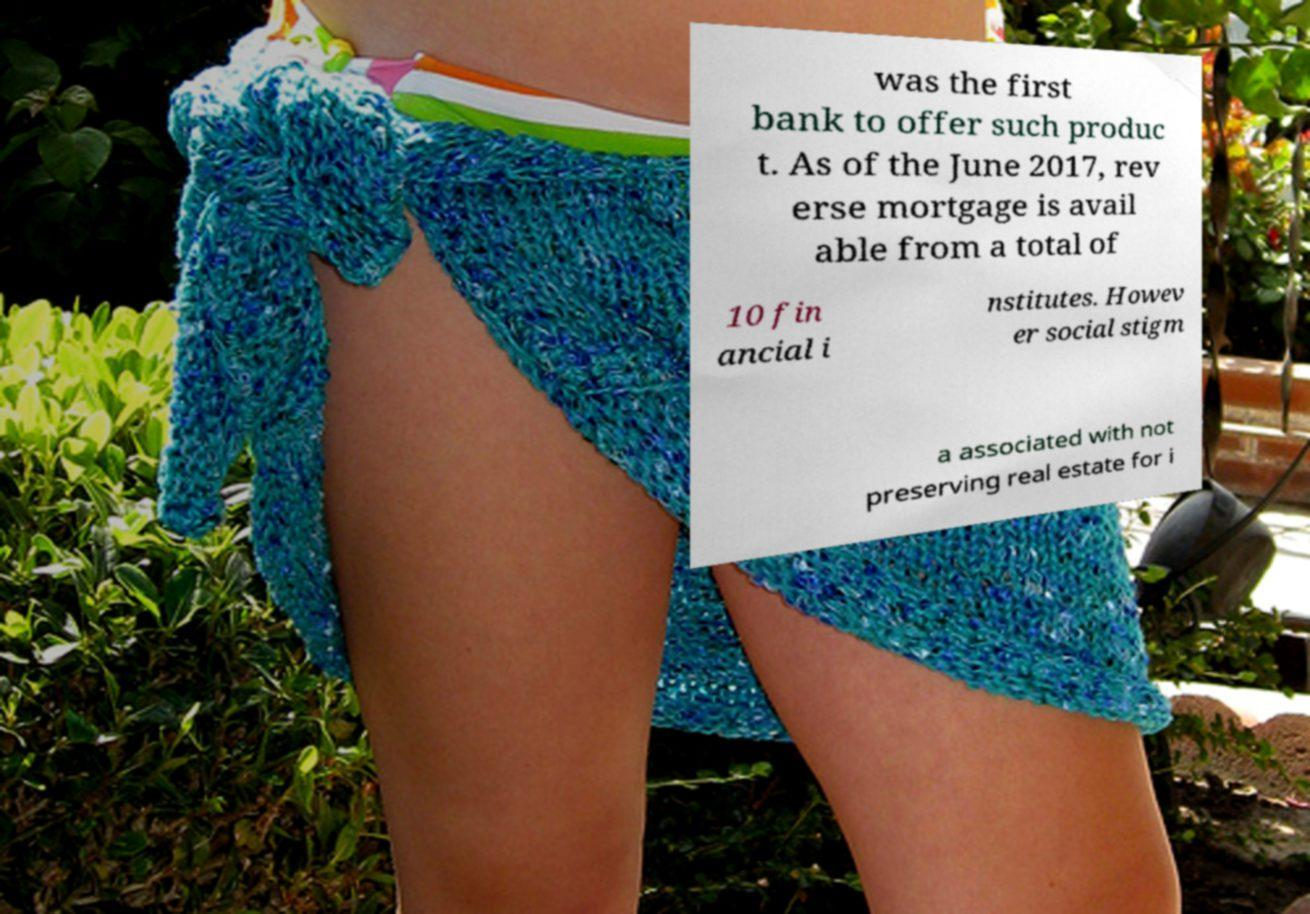Could you extract and type out the text from this image? was the first bank to offer such produc t. As of the June 2017, rev erse mortgage is avail able from a total of 10 fin ancial i nstitutes. Howev er social stigm a associated with not preserving real estate for i 